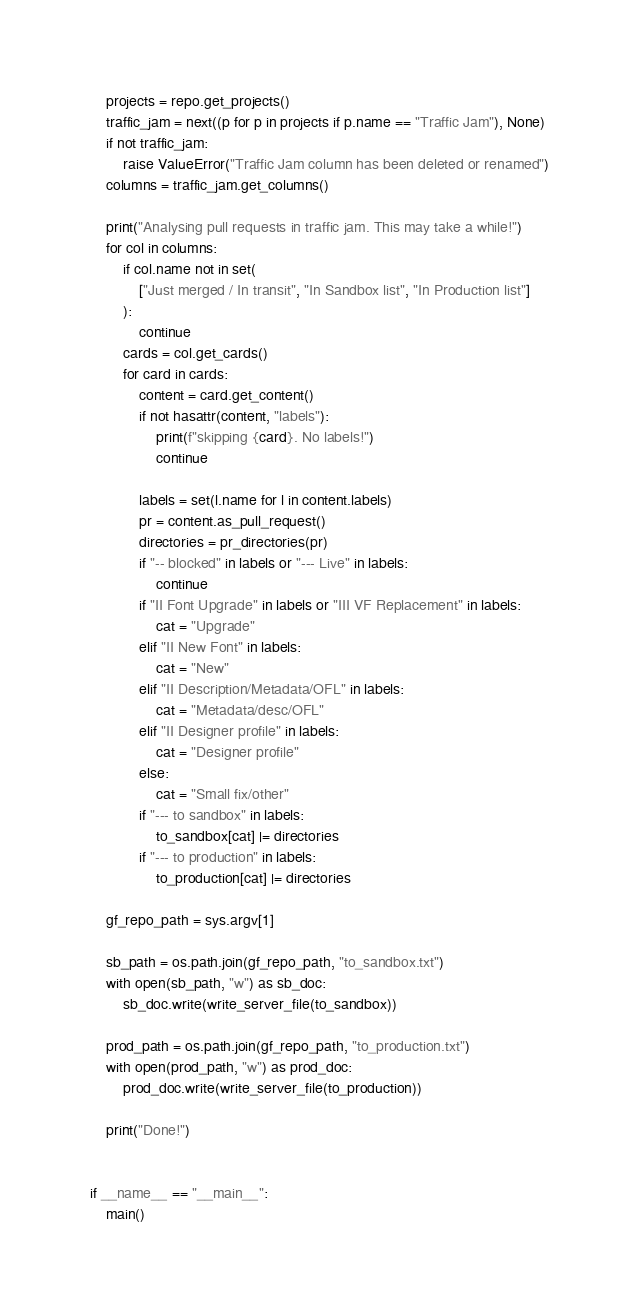Convert code to text. <code><loc_0><loc_0><loc_500><loc_500><_Python_>
    projects = repo.get_projects()
    traffic_jam = next((p for p in projects if p.name == "Traffic Jam"), None)
    if not traffic_jam:
        raise ValueError("Traffic Jam column has been deleted or renamed")
    columns = traffic_jam.get_columns()

    print("Analysing pull requests in traffic jam. This may take a while!")
    for col in columns:
        if col.name not in set(
            ["Just merged / In transit", "In Sandbox list", "In Production list"]
        ):
            continue
        cards = col.get_cards()
        for card in cards:
            content = card.get_content()
            if not hasattr(content, "labels"):
                print(f"skipping {card}. No labels!")
                continue

            labels = set(l.name for l in content.labels)
            pr = content.as_pull_request()
            directories = pr_directories(pr)
            if "-- blocked" in labels or "--- Live" in labels:
                continue
            if "II Font Upgrade" in labels or "III VF Replacement" in labels:
                cat = "Upgrade"
            elif "II New Font" in labels:
                cat = "New"
            elif "II Description/Metadata/OFL" in labels:
                cat = "Metadata/desc/OFL"
            elif "II Designer profile" in labels:
                cat = "Designer profile"
            else:
                cat = "Small fix/other"
            if "--- to sandbox" in labels:
                to_sandbox[cat] |= directories
            if "--- to production" in labels:
                to_production[cat] |= directories

    gf_repo_path = sys.argv[1]

    sb_path = os.path.join(gf_repo_path, "to_sandbox.txt")
    with open(sb_path, "w") as sb_doc:
        sb_doc.write(write_server_file(to_sandbox))

    prod_path = os.path.join(gf_repo_path, "to_production.txt")
    with open(prod_path, "w") as prod_doc:
        prod_doc.write(write_server_file(to_production))

    print("Done!")


if __name__ == "__main__":
    main()
</code> 